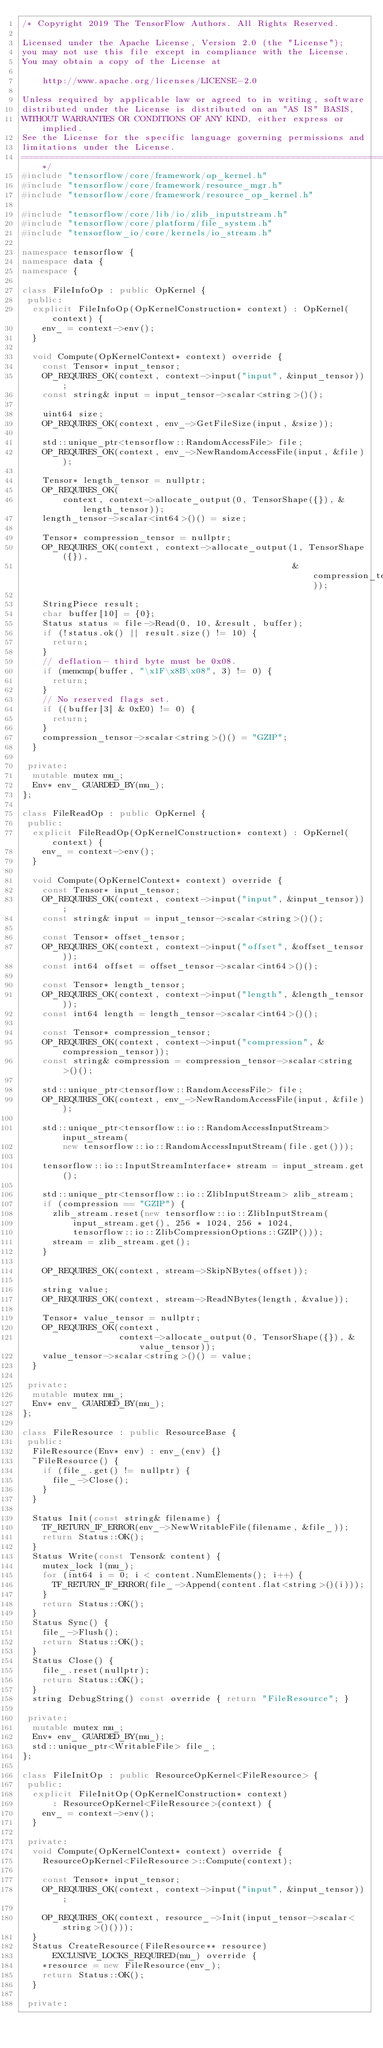Convert code to text. <code><loc_0><loc_0><loc_500><loc_500><_C++_>/* Copyright 2019 The TensorFlow Authors. All Rights Reserved.

Licensed under the Apache License, Version 2.0 (the "License");
you may not use this file except in compliance with the License.
You may obtain a copy of the License at

    http://www.apache.org/licenses/LICENSE-2.0

Unless required by applicable law or agreed to in writing, software
distributed under the License is distributed on an "AS IS" BASIS,
WITHOUT WARRANTIES OR CONDITIONS OF ANY KIND, either express or implied.
See the License for the specific language governing permissions and
limitations under the License.
==============================================================================*/
#include "tensorflow/core/framework/op_kernel.h"
#include "tensorflow/core/framework/resource_mgr.h"
#include "tensorflow/core/framework/resource_op_kernel.h"

#include "tensorflow/core/lib/io/zlib_inputstream.h"
#include "tensorflow/core/platform/file_system.h"
#include "tensorflow_io/core/kernels/io_stream.h"

namespace tensorflow {
namespace data {
namespace {

class FileInfoOp : public OpKernel {
 public:
  explicit FileInfoOp(OpKernelConstruction* context) : OpKernel(context) {
    env_ = context->env();
  }

  void Compute(OpKernelContext* context) override {
    const Tensor* input_tensor;
    OP_REQUIRES_OK(context, context->input("input", &input_tensor));
    const string& input = input_tensor->scalar<string>()();

    uint64 size;
    OP_REQUIRES_OK(context, env_->GetFileSize(input, &size));

    std::unique_ptr<tensorflow::RandomAccessFile> file;
    OP_REQUIRES_OK(context, env_->NewRandomAccessFile(input, &file));

    Tensor* length_tensor = nullptr;
    OP_REQUIRES_OK(
        context, context->allocate_output(0, TensorShape({}), &length_tensor));
    length_tensor->scalar<int64>()() = size;

    Tensor* compression_tensor = nullptr;
    OP_REQUIRES_OK(context, context->allocate_output(1, TensorShape({}),
                                                     &compression_tensor));

    StringPiece result;
    char buffer[10] = {0};
    Status status = file->Read(0, 10, &result, buffer);
    if (!status.ok() || result.size() != 10) {
      return;
    }
    // deflation- third byte must be 0x08.
    if (memcmp(buffer, "\x1F\x8B\x08", 3) != 0) {
      return;
    }
    // No reserved flags set.
    if ((buffer[3] & 0xE0) != 0) {
      return;
    }
    compression_tensor->scalar<string>()() = "GZIP";
  }

 private:
  mutable mutex mu_;
  Env* env_ GUARDED_BY(mu_);
};

class FileReadOp : public OpKernel {
 public:
  explicit FileReadOp(OpKernelConstruction* context) : OpKernel(context) {
    env_ = context->env();
  }

  void Compute(OpKernelContext* context) override {
    const Tensor* input_tensor;
    OP_REQUIRES_OK(context, context->input("input", &input_tensor));
    const string& input = input_tensor->scalar<string>()();

    const Tensor* offset_tensor;
    OP_REQUIRES_OK(context, context->input("offset", &offset_tensor));
    const int64 offset = offset_tensor->scalar<int64>()();

    const Tensor* length_tensor;
    OP_REQUIRES_OK(context, context->input("length", &length_tensor));
    const int64 length = length_tensor->scalar<int64>()();

    const Tensor* compression_tensor;
    OP_REQUIRES_OK(context, context->input("compression", &compression_tensor));
    const string& compression = compression_tensor->scalar<string>()();

    std::unique_ptr<tensorflow::RandomAccessFile> file;
    OP_REQUIRES_OK(context, env_->NewRandomAccessFile(input, &file));

    std::unique_ptr<tensorflow::io::RandomAccessInputStream> input_stream(
        new tensorflow::io::RandomAccessInputStream(file.get()));

    tensorflow::io::InputStreamInterface* stream = input_stream.get();

    std::unique_ptr<tensorflow::io::ZlibInputStream> zlib_stream;
    if (compression == "GZIP") {
      zlib_stream.reset(new tensorflow::io::ZlibInputStream(
          input_stream.get(), 256 * 1024, 256 * 1024,
          tensorflow::io::ZlibCompressionOptions::GZIP()));
      stream = zlib_stream.get();
    }

    OP_REQUIRES_OK(context, stream->SkipNBytes(offset));

    string value;
    OP_REQUIRES_OK(context, stream->ReadNBytes(length, &value));

    Tensor* value_tensor = nullptr;
    OP_REQUIRES_OK(context,
                   context->allocate_output(0, TensorShape({}), &value_tensor));
    value_tensor->scalar<string>()() = value;
  }

 private:
  mutable mutex mu_;
  Env* env_ GUARDED_BY(mu_);
};

class FileResource : public ResourceBase {
 public:
  FileResource(Env* env) : env_(env) {}
  ~FileResource() {
    if (file_.get() != nullptr) {
      file_->Close();
    }
  }

  Status Init(const string& filename) {
    TF_RETURN_IF_ERROR(env_->NewWritableFile(filename, &file_));
    return Status::OK();
  }
  Status Write(const Tensor& content) {
    mutex_lock l(mu_);
    for (int64 i = 0; i < content.NumElements(); i++) {
      TF_RETURN_IF_ERROR(file_->Append(content.flat<string>()(i)));
    }
    return Status::OK();
  }
  Status Sync() {
    file_->Flush();
    return Status::OK();
  }
  Status Close() {
    file_.reset(nullptr);
    return Status::OK();
  }
  string DebugString() const override { return "FileResource"; }

 private:
  mutable mutex mu_;
  Env* env_ GUARDED_BY(mu_);
  std::unique_ptr<WritableFile> file_;
};

class FileInitOp : public ResourceOpKernel<FileResource> {
 public:
  explicit FileInitOp(OpKernelConstruction* context)
      : ResourceOpKernel<FileResource>(context) {
    env_ = context->env();
  }

 private:
  void Compute(OpKernelContext* context) override {
    ResourceOpKernel<FileResource>::Compute(context);

    const Tensor* input_tensor;
    OP_REQUIRES_OK(context, context->input("input", &input_tensor));

    OP_REQUIRES_OK(context, resource_->Init(input_tensor->scalar<string>()()));
  }
  Status CreateResource(FileResource** resource)
      EXCLUSIVE_LOCKS_REQUIRED(mu_) override {
    *resource = new FileResource(env_);
    return Status::OK();
  }

 private:</code> 